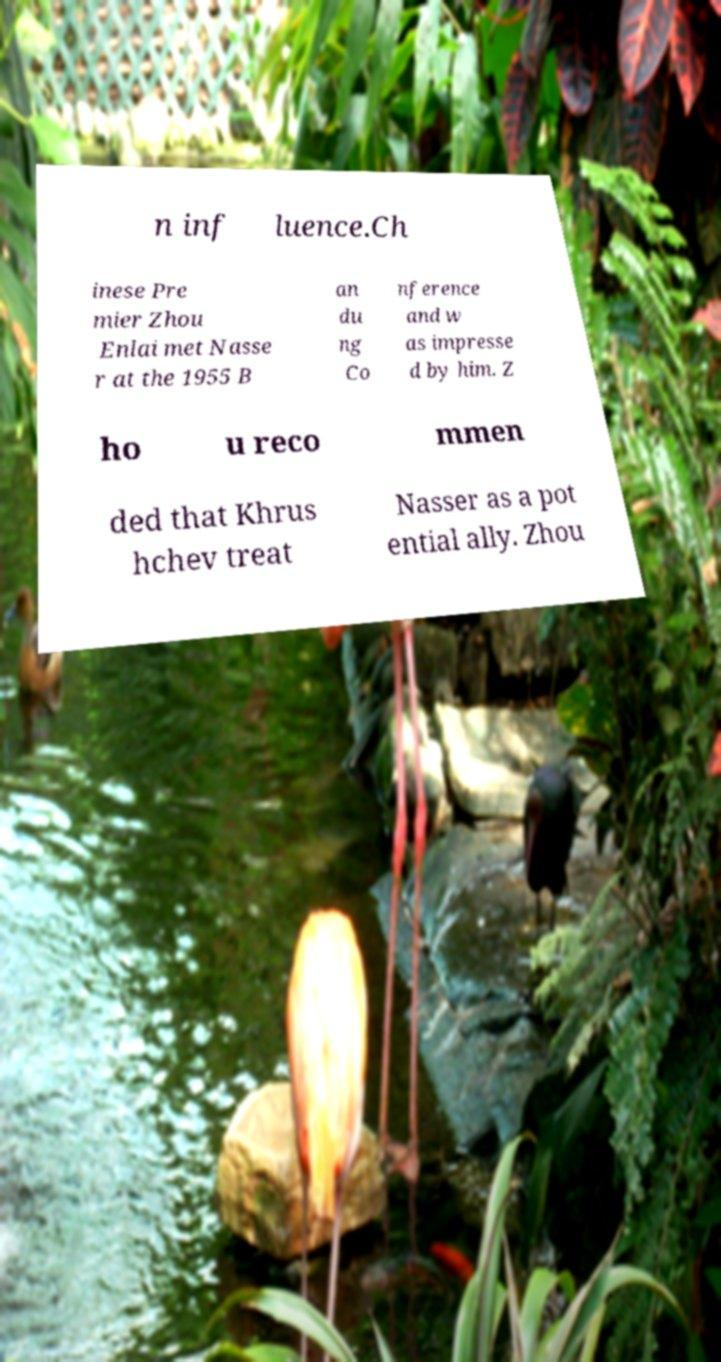What messages or text are displayed in this image? I need them in a readable, typed format. n inf luence.Ch inese Pre mier Zhou Enlai met Nasse r at the 1955 B an du ng Co nference and w as impresse d by him. Z ho u reco mmen ded that Khrus hchev treat Nasser as a pot ential ally. Zhou 